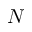<formula> <loc_0><loc_0><loc_500><loc_500>N</formula> 